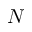<formula> <loc_0><loc_0><loc_500><loc_500>N</formula> 